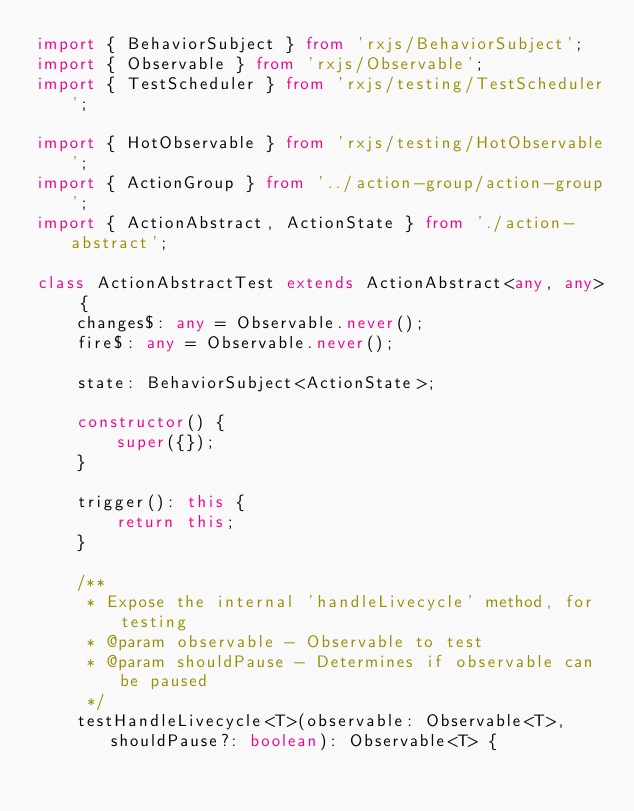Convert code to text. <code><loc_0><loc_0><loc_500><loc_500><_TypeScript_>import { BehaviorSubject } from 'rxjs/BehaviorSubject';
import { Observable } from 'rxjs/Observable';
import { TestScheduler } from 'rxjs/testing/TestScheduler';

import { HotObservable } from 'rxjs/testing/HotObservable';
import { ActionGroup } from '../action-group/action-group';
import { ActionAbstract, ActionState } from './action-abstract';

class ActionAbstractTest extends ActionAbstract<any, any> {
    changes$: any = Observable.never();
    fire$: any = Observable.never();

    state: BehaviorSubject<ActionState>;

    constructor() {
        super({});
    }

    trigger(): this {
        return this;
    }

    /**
     * Expose the internal 'handleLivecycle' method, for testing
     * @param observable - Observable to test
     * @param shouldPause - Determines if observable can be paused
     */
    testHandleLivecycle<T>(observable: Observable<T>, shouldPause?: boolean): Observable<T> {</code> 